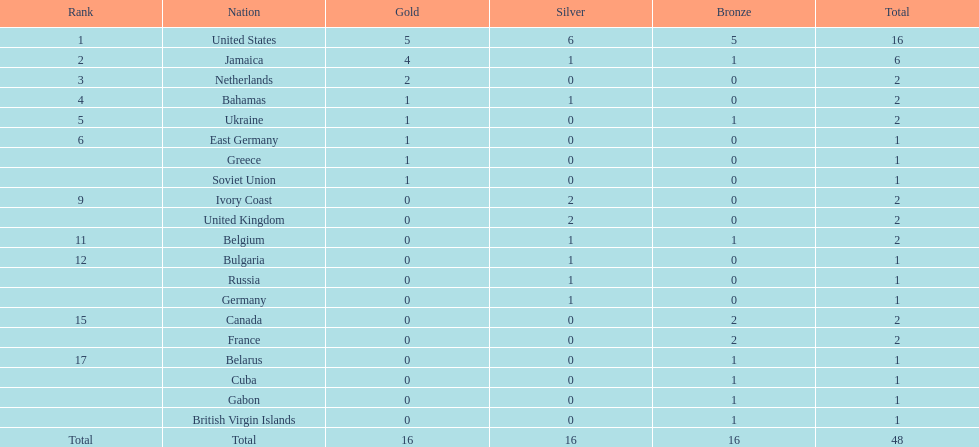What number of nations received 1 medal? 10. 